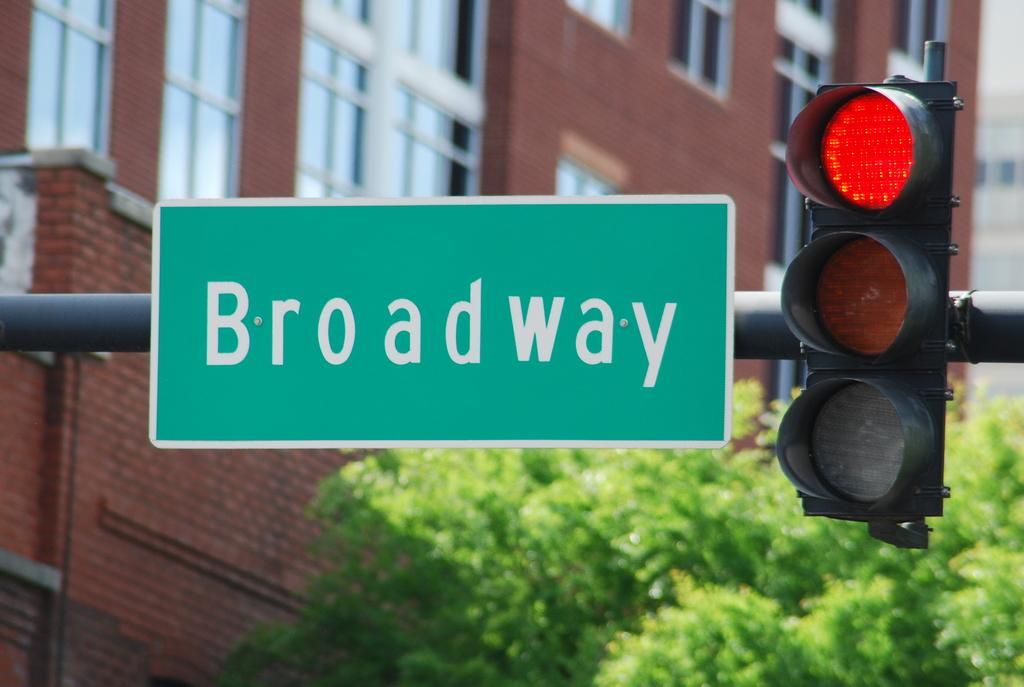Provide a one-sentence caption for the provided image. The light at the Broadway intersection is red. 